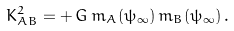Convert formula to latex. <formula><loc_0><loc_0><loc_500><loc_500>K _ { A B } ^ { 2 } = + \, G \, m _ { A } ( \psi _ { \infty } ) \, m _ { B } ( \psi _ { \infty } ) \, .</formula> 